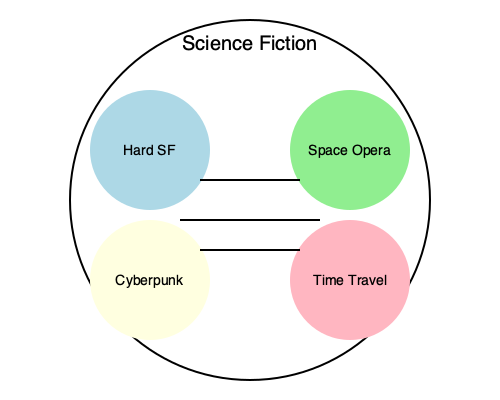Based on the interconnections shown in the diagram, which subgenre of Science Fiction appears to have the most direct connections to other subgenres, potentially indicating its central role in bridging different themes within the genre? To answer this question, we need to analyze the connections between the subgenres shown in the diagram:

1. The diagram shows four subgenres of Science Fiction: Hard SF, Space Opera, Cyberpunk, and Time Travel.

2. We can see lines connecting these subgenres, representing interconnections or shared themes.

3. Let's count the connections for each subgenre:
   - Hard SF: 2 connections (to Space Opera and Cyberpunk)
   - Space Opera: 3 connections (to Hard SF, Cyberpunk, and Time Travel)
   - Cyberpunk: 3 connections (to Hard SF, Space Opera, and Time Travel)
   - Time Travel: 2 connections (to Space Opera and Cyberpunk)

4. Both Space Opera and Cyberpunk have the highest number of connections (3 each).

5. However, Space Opera is positioned more centrally in the diagram, suggesting it might play a slightly more central role in bridging the different themes.

6. As a literary agent specializing in Science Fiction, recognizing Space Opera's central position could be valuable for understanding its broad appeal and potential for cross-pollination with other subgenres.

Therefore, based on the diagram and its relevance to a literary agent's perspective, Space Opera appears to have the most direct connections and a central position in bridging different themes within Science Fiction.
Answer: Space Opera 